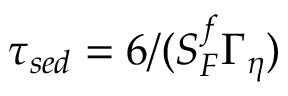<formula> <loc_0><loc_0><loc_500><loc_500>\tau _ { s e d } = 6 / ( S _ { F } ^ { f } \Gamma _ { \eta } )</formula> 